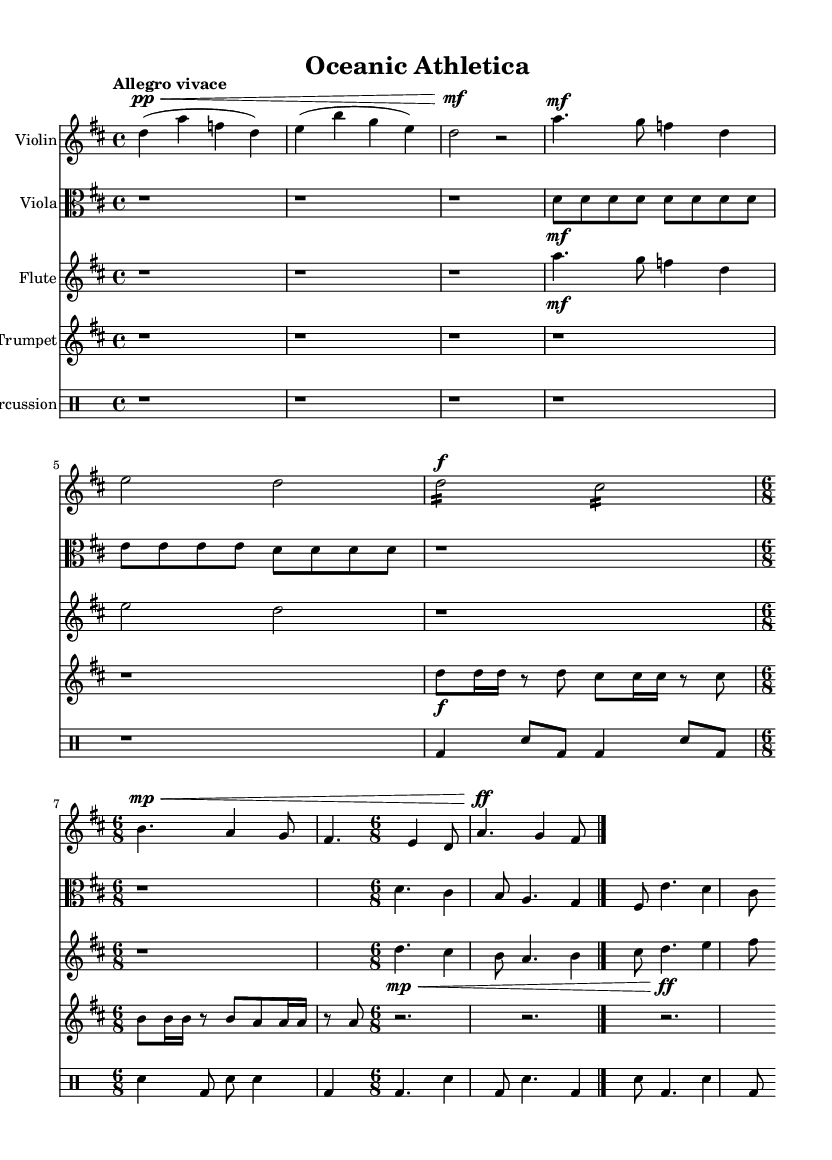What is the key signature of this music? The key signature is D major, which has two sharps (F# and C#). This can be identified at the beginning of the score, at the start of each staff.
Answer: D major What is the time signature of the piece? The time signature present throughout most of the piece is 4/4, which can be determined from the top of the sheet music and is consistent in multiple sections. Additionally, a 6/8 time signature appears during Theme C, but 4/4 is the main signature.
Answer: 4/4 What is the tempo marking for this symphony? The tempo marking is "Allegro vivace," indicated at the beginning of the score, which denotes a lively and brisk pace for the music.
Answer: Allegro vivace Which instrument plays the Introduction in the first part of the piece? The Violin plays the Introduction in the first part of the piece, as indicated by the single staff for violin notation at the top of the sheet music segment provided.
Answer: Violin How many themes are presented in this symphony? Three themes are present, labeled as Theme A (Swimming), Theme B (Rugby), and Theme C (Surfing). Each theme is distinctly outlined in the score.
Answer: Three What is the dynamic marking for Theme B performed by the trumpet? The dynamic marking for Theme B performed by the trumpet is forte, which is indicated by the "f" notated in the trumpet staff during the rhythm section of this theme.
Answer: Forte 